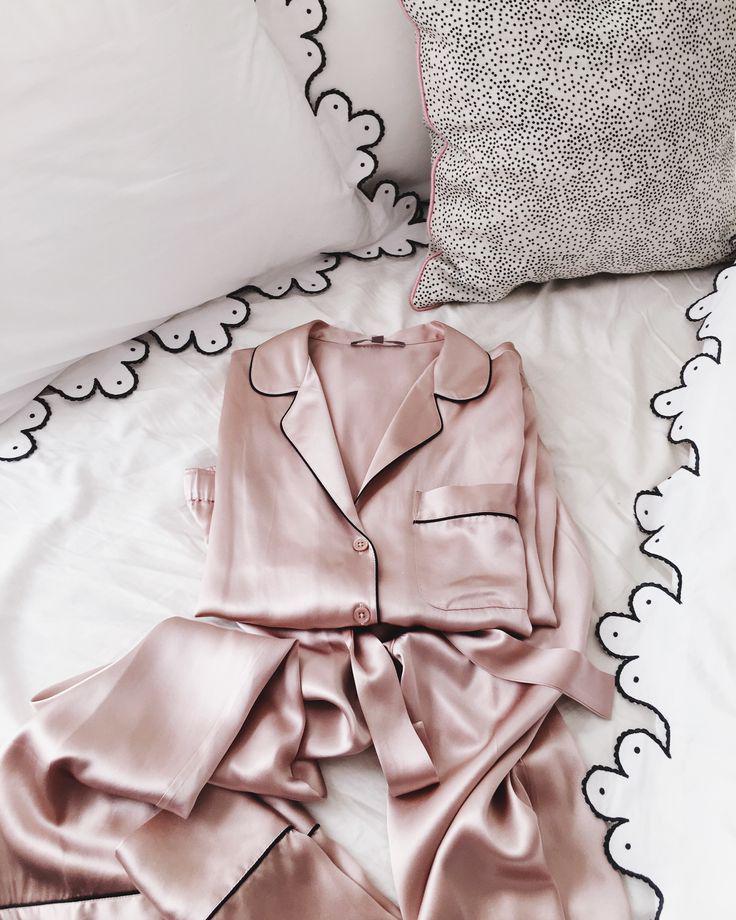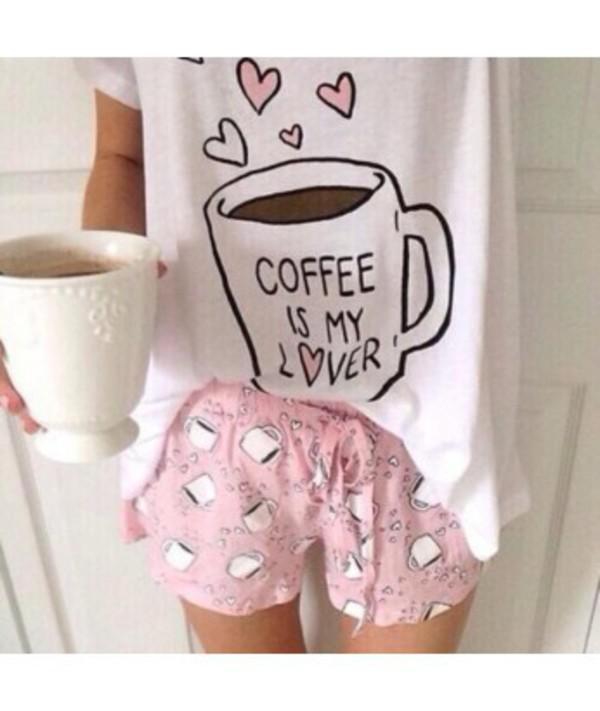The first image is the image on the left, the second image is the image on the right. Analyze the images presented: Is the assertion "At least one pajama is one piece and has a card or paper near it was a brand name." valid? Answer yes or no. No. The first image is the image on the left, the second image is the image on the right. Examine the images to the left and right. Is the description "There is only one single piece outfit and only one two piece outfit." accurate? Answer yes or no. No. 